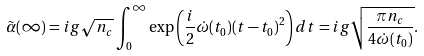<formula> <loc_0><loc_0><loc_500><loc_500>\tilde { \alpha } ( \infty ) = i g \sqrt { n _ { c } } \int _ { 0 } ^ { \infty } \exp \left ( \frac { i } { 2 } \dot { \omega } ( t _ { 0 } ) ( t - t _ { 0 } ) ^ { 2 } \right ) d t = i g \sqrt { \frac { \pi n _ { c } } { 4 \dot { \omega } ( t _ { 0 } { ) } } } .</formula> 